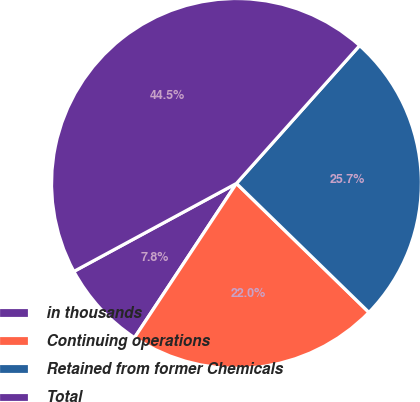Convert chart. <chart><loc_0><loc_0><loc_500><loc_500><pie_chart><fcel>in thousands<fcel>Continuing operations<fcel>Retained from former Chemicals<fcel>Total<nl><fcel>7.81%<fcel>22.01%<fcel>25.68%<fcel>44.5%<nl></chart> 